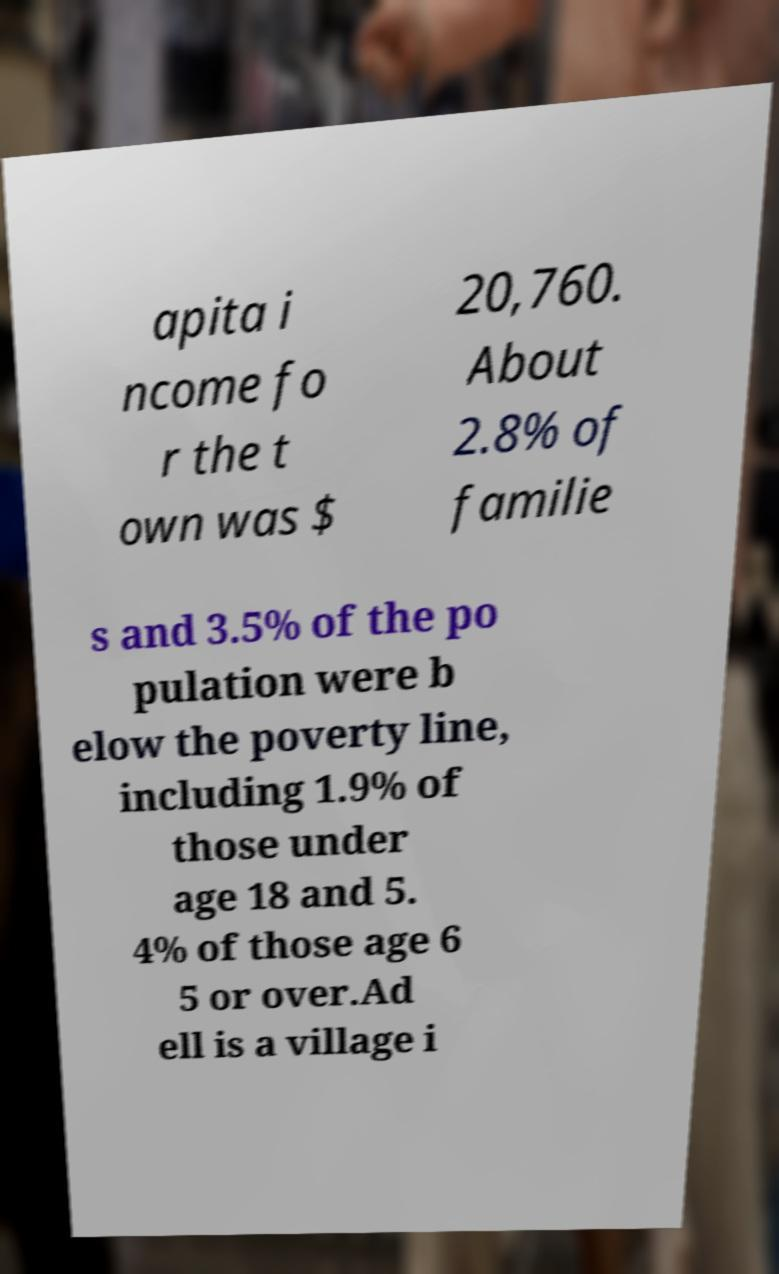Can you accurately transcribe the text from the provided image for me? apita i ncome fo r the t own was $ 20,760. About 2.8% of familie s and 3.5% of the po pulation were b elow the poverty line, including 1.9% of those under age 18 and 5. 4% of those age 6 5 or over.Ad ell is a village i 